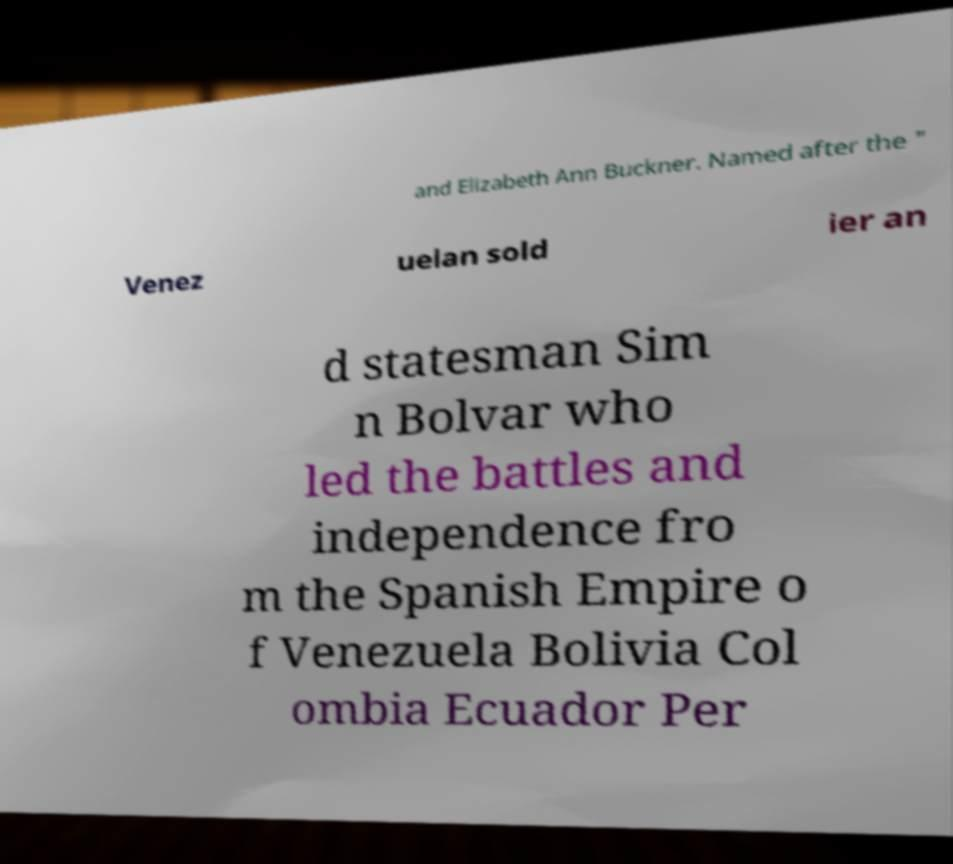Can you read and provide the text displayed in the image?This photo seems to have some interesting text. Can you extract and type it out for me? and Elizabeth Ann Buckner. Named after the " Venez uelan sold ier an d statesman Sim n Bolvar who led the battles and independence fro m the Spanish Empire o f Venezuela Bolivia Col ombia Ecuador Per 